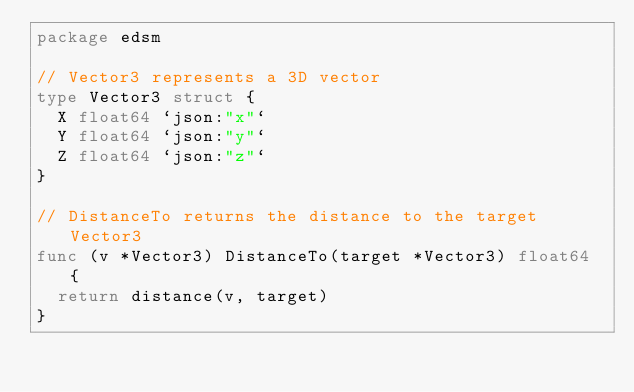<code> <loc_0><loc_0><loc_500><loc_500><_Go_>package edsm

// Vector3 represents a 3D vector
type Vector3 struct {
	X float64 `json:"x"`
	Y float64 `json:"y"`
	Z float64 `json:"z"`
}

// DistanceTo returns the distance to the target Vector3
func (v *Vector3) DistanceTo(target *Vector3) float64 {
	return distance(v, target)
}
</code> 